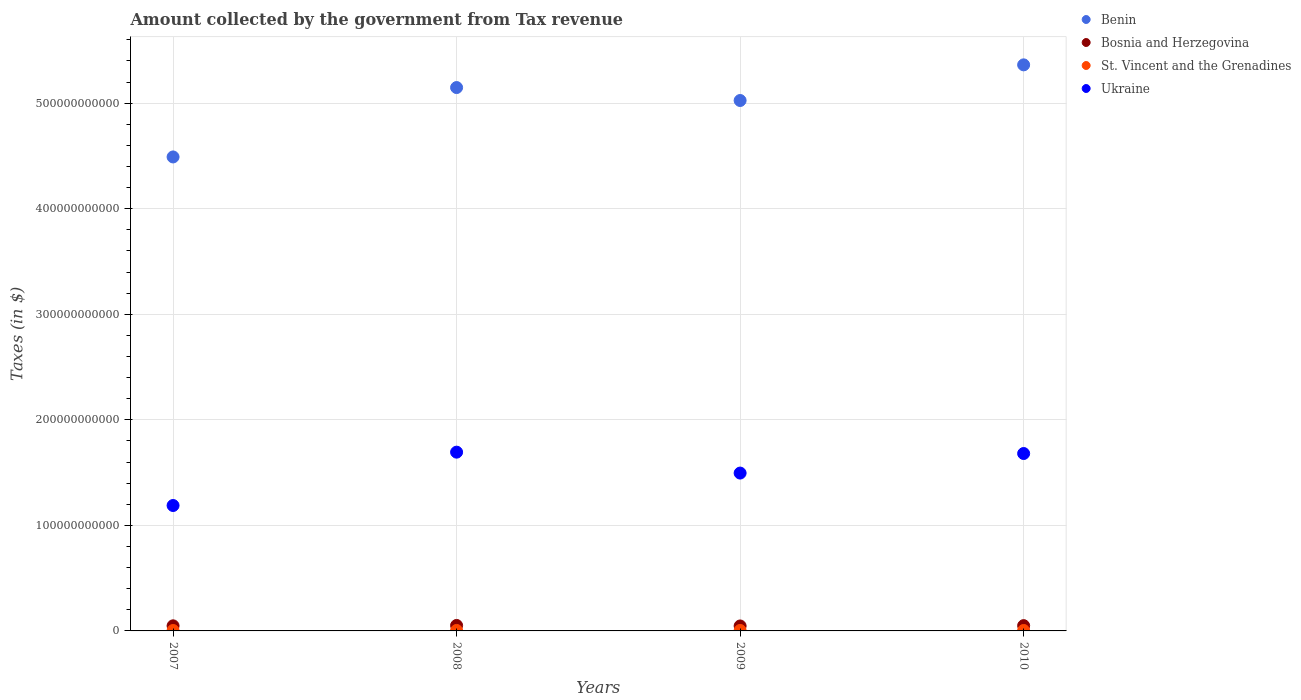What is the amount collected by the government from tax revenue in Bosnia and Herzegovina in 2007?
Your answer should be compact. 4.82e+09. Across all years, what is the maximum amount collected by the government from tax revenue in Bosnia and Herzegovina?
Give a very brief answer. 5.18e+09. Across all years, what is the minimum amount collected by the government from tax revenue in St. Vincent and the Grenadines?
Ensure brevity in your answer.  4.03e+08. In which year was the amount collected by the government from tax revenue in Bosnia and Herzegovina maximum?
Your answer should be very brief. 2008. What is the total amount collected by the government from tax revenue in Bosnia and Herzegovina in the graph?
Offer a terse response. 1.97e+1. What is the difference between the amount collected by the government from tax revenue in Benin in 2007 and that in 2010?
Your response must be concise. -8.72e+1. What is the difference between the amount collected by the government from tax revenue in Bosnia and Herzegovina in 2009 and the amount collected by the government from tax revenue in St. Vincent and the Grenadines in 2010?
Make the answer very short. 4.28e+09. What is the average amount collected by the government from tax revenue in St. Vincent and the Grenadines per year?
Provide a short and direct response. 4.26e+08. In the year 2008, what is the difference between the amount collected by the government from tax revenue in Bosnia and Herzegovina and amount collected by the government from tax revenue in Benin?
Your answer should be compact. -5.10e+11. In how many years, is the amount collected by the government from tax revenue in Bosnia and Herzegovina greater than 300000000000 $?
Provide a succinct answer. 0. What is the ratio of the amount collected by the government from tax revenue in St. Vincent and the Grenadines in 2007 to that in 2008?
Your answer should be compact. 0.9. Is the amount collected by the government from tax revenue in Benin in 2008 less than that in 2009?
Give a very brief answer. No. What is the difference between the highest and the second highest amount collected by the government from tax revenue in St. Vincent and the Grenadines?
Ensure brevity in your answer.  1.54e+07. What is the difference between the highest and the lowest amount collected by the government from tax revenue in St. Vincent and the Grenadines?
Your answer should be very brief. 4.54e+07. Is the sum of the amount collected by the government from tax revenue in Bosnia and Herzegovina in 2008 and 2009 greater than the maximum amount collected by the government from tax revenue in St. Vincent and the Grenadines across all years?
Ensure brevity in your answer.  Yes. Is it the case that in every year, the sum of the amount collected by the government from tax revenue in Ukraine and amount collected by the government from tax revenue in Benin  is greater than the sum of amount collected by the government from tax revenue in St. Vincent and the Grenadines and amount collected by the government from tax revenue in Bosnia and Herzegovina?
Offer a terse response. No. Does the amount collected by the government from tax revenue in Ukraine monotonically increase over the years?
Offer a terse response. No. How many dotlines are there?
Keep it short and to the point. 4. How many years are there in the graph?
Offer a very short reply. 4. What is the difference between two consecutive major ticks on the Y-axis?
Provide a succinct answer. 1.00e+11. Are the values on the major ticks of Y-axis written in scientific E-notation?
Make the answer very short. No. Where does the legend appear in the graph?
Offer a terse response. Top right. How many legend labels are there?
Provide a succinct answer. 4. What is the title of the graph?
Keep it short and to the point. Amount collected by the government from Tax revenue. Does "Denmark" appear as one of the legend labels in the graph?
Provide a short and direct response. No. What is the label or title of the Y-axis?
Offer a terse response. Taxes (in $). What is the Taxes (in $) in Benin in 2007?
Your response must be concise. 4.49e+11. What is the Taxes (in $) in Bosnia and Herzegovina in 2007?
Keep it short and to the point. 4.82e+09. What is the Taxes (in $) of St. Vincent and the Grenadines in 2007?
Ensure brevity in your answer.  4.03e+08. What is the Taxes (in $) in Ukraine in 2007?
Give a very brief answer. 1.19e+11. What is the Taxes (in $) in Benin in 2008?
Offer a very short reply. 5.15e+11. What is the Taxes (in $) of Bosnia and Herzegovina in 2008?
Keep it short and to the point. 5.18e+09. What is the Taxes (in $) in St. Vincent and the Grenadines in 2008?
Your answer should be compact. 4.48e+08. What is the Taxes (in $) of Ukraine in 2008?
Keep it short and to the point. 1.69e+11. What is the Taxes (in $) of Benin in 2009?
Your answer should be compact. 5.02e+11. What is the Taxes (in $) in Bosnia and Herzegovina in 2009?
Your answer should be compact. 4.70e+09. What is the Taxes (in $) in St. Vincent and the Grenadines in 2009?
Your answer should be very brief. 4.33e+08. What is the Taxes (in $) in Ukraine in 2009?
Offer a terse response. 1.50e+11. What is the Taxes (in $) of Benin in 2010?
Offer a terse response. 5.36e+11. What is the Taxes (in $) in Bosnia and Herzegovina in 2010?
Offer a terse response. 4.99e+09. What is the Taxes (in $) in St. Vincent and the Grenadines in 2010?
Provide a succinct answer. 4.22e+08. What is the Taxes (in $) of Ukraine in 2010?
Provide a short and direct response. 1.68e+11. Across all years, what is the maximum Taxes (in $) in Benin?
Offer a very short reply. 5.36e+11. Across all years, what is the maximum Taxes (in $) in Bosnia and Herzegovina?
Give a very brief answer. 5.18e+09. Across all years, what is the maximum Taxes (in $) of St. Vincent and the Grenadines?
Your response must be concise. 4.48e+08. Across all years, what is the maximum Taxes (in $) in Ukraine?
Provide a short and direct response. 1.69e+11. Across all years, what is the minimum Taxes (in $) of Benin?
Offer a terse response. 4.49e+11. Across all years, what is the minimum Taxes (in $) in Bosnia and Herzegovina?
Offer a very short reply. 4.70e+09. Across all years, what is the minimum Taxes (in $) of St. Vincent and the Grenadines?
Offer a terse response. 4.03e+08. Across all years, what is the minimum Taxes (in $) in Ukraine?
Your answer should be compact. 1.19e+11. What is the total Taxes (in $) in Benin in the graph?
Offer a terse response. 2.00e+12. What is the total Taxes (in $) of Bosnia and Herzegovina in the graph?
Ensure brevity in your answer.  1.97e+1. What is the total Taxes (in $) in St. Vincent and the Grenadines in the graph?
Make the answer very short. 1.70e+09. What is the total Taxes (in $) in Ukraine in the graph?
Your answer should be compact. 6.06e+11. What is the difference between the Taxes (in $) in Benin in 2007 and that in 2008?
Your answer should be very brief. -6.57e+1. What is the difference between the Taxes (in $) in Bosnia and Herzegovina in 2007 and that in 2008?
Ensure brevity in your answer.  -3.57e+08. What is the difference between the Taxes (in $) of St. Vincent and the Grenadines in 2007 and that in 2008?
Your response must be concise. -4.54e+07. What is the difference between the Taxes (in $) of Ukraine in 2007 and that in 2008?
Your answer should be compact. -5.05e+1. What is the difference between the Taxes (in $) of Benin in 2007 and that in 2009?
Provide a succinct answer. -5.35e+1. What is the difference between the Taxes (in $) in Bosnia and Herzegovina in 2007 and that in 2009?
Your response must be concise. 1.26e+08. What is the difference between the Taxes (in $) of St. Vincent and the Grenadines in 2007 and that in 2009?
Ensure brevity in your answer.  -3.00e+07. What is the difference between the Taxes (in $) of Ukraine in 2007 and that in 2009?
Make the answer very short. -3.07e+1. What is the difference between the Taxes (in $) in Benin in 2007 and that in 2010?
Give a very brief answer. -8.72e+1. What is the difference between the Taxes (in $) in Bosnia and Herzegovina in 2007 and that in 2010?
Provide a succinct answer. -1.69e+08. What is the difference between the Taxes (in $) in St. Vincent and the Grenadines in 2007 and that in 2010?
Your response must be concise. -1.89e+07. What is the difference between the Taxes (in $) of Ukraine in 2007 and that in 2010?
Make the answer very short. -4.93e+1. What is the difference between the Taxes (in $) in Benin in 2008 and that in 2009?
Your answer should be compact. 1.23e+1. What is the difference between the Taxes (in $) in Bosnia and Herzegovina in 2008 and that in 2009?
Offer a very short reply. 4.83e+08. What is the difference between the Taxes (in $) of St. Vincent and the Grenadines in 2008 and that in 2009?
Offer a terse response. 1.54e+07. What is the difference between the Taxes (in $) of Ukraine in 2008 and that in 2009?
Ensure brevity in your answer.  1.98e+1. What is the difference between the Taxes (in $) in Benin in 2008 and that in 2010?
Your response must be concise. -2.15e+1. What is the difference between the Taxes (in $) in Bosnia and Herzegovina in 2008 and that in 2010?
Your response must be concise. 1.88e+08. What is the difference between the Taxes (in $) in St. Vincent and the Grenadines in 2008 and that in 2010?
Offer a very short reply. 2.65e+07. What is the difference between the Taxes (in $) of Ukraine in 2008 and that in 2010?
Your response must be concise. 1.29e+09. What is the difference between the Taxes (in $) of Benin in 2009 and that in 2010?
Give a very brief answer. -3.38e+1. What is the difference between the Taxes (in $) in Bosnia and Herzegovina in 2009 and that in 2010?
Your answer should be compact. -2.95e+08. What is the difference between the Taxes (in $) of St. Vincent and the Grenadines in 2009 and that in 2010?
Keep it short and to the point. 1.11e+07. What is the difference between the Taxes (in $) of Ukraine in 2009 and that in 2010?
Your response must be concise. -1.85e+1. What is the difference between the Taxes (in $) of Benin in 2007 and the Taxes (in $) of Bosnia and Herzegovina in 2008?
Provide a succinct answer. 4.44e+11. What is the difference between the Taxes (in $) in Benin in 2007 and the Taxes (in $) in St. Vincent and the Grenadines in 2008?
Provide a short and direct response. 4.49e+11. What is the difference between the Taxes (in $) of Benin in 2007 and the Taxes (in $) of Ukraine in 2008?
Your response must be concise. 2.80e+11. What is the difference between the Taxes (in $) in Bosnia and Herzegovina in 2007 and the Taxes (in $) in St. Vincent and the Grenadines in 2008?
Offer a terse response. 4.38e+09. What is the difference between the Taxes (in $) in Bosnia and Herzegovina in 2007 and the Taxes (in $) in Ukraine in 2008?
Provide a succinct answer. -1.65e+11. What is the difference between the Taxes (in $) in St. Vincent and the Grenadines in 2007 and the Taxes (in $) in Ukraine in 2008?
Your response must be concise. -1.69e+11. What is the difference between the Taxes (in $) in Benin in 2007 and the Taxes (in $) in Bosnia and Herzegovina in 2009?
Give a very brief answer. 4.44e+11. What is the difference between the Taxes (in $) in Benin in 2007 and the Taxes (in $) in St. Vincent and the Grenadines in 2009?
Your response must be concise. 4.49e+11. What is the difference between the Taxes (in $) in Benin in 2007 and the Taxes (in $) in Ukraine in 2009?
Your response must be concise. 2.99e+11. What is the difference between the Taxes (in $) in Bosnia and Herzegovina in 2007 and the Taxes (in $) in St. Vincent and the Grenadines in 2009?
Offer a very short reply. 4.39e+09. What is the difference between the Taxes (in $) of Bosnia and Herzegovina in 2007 and the Taxes (in $) of Ukraine in 2009?
Give a very brief answer. -1.45e+11. What is the difference between the Taxes (in $) of St. Vincent and the Grenadines in 2007 and the Taxes (in $) of Ukraine in 2009?
Provide a succinct answer. -1.49e+11. What is the difference between the Taxes (in $) in Benin in 2007 and the Taxes (in $) in Bosnia and Herzegovina in 2010?
Your answer should be compact. 4.44e+11. What is the difference between the Taxes (in $) of Benin in 2007 and the Taxes (in $) of St. Vincent and the Grenadines in 2010?
Keep it short and to the point. 4.49e+11. What is the difference between the Taxes (in $) of Benin in 2007 and the Taxes (in $) of Ukraine in 2010?
Give a very brief answer. 2.81e+11. What is the difference between the Taxes (in $) in Bosnia and Herzegovina in 2007 and the Taxes (in $) in St. Vincent and the Grenadines in 2010?
Keep it short and to the point. 4.40e+09. What is the difference between the Taxes (in $) of Bosnia and Herzegovina in 2007 and the Taxes (in $) of Ukraine in 2010?
Keep it short and to the point. -1.63e+11. What is the difference between the Taxes (in $) of St. Vincent and the Grenadines in 2007 and the Taxes (in $) of Ukraine in 2010?
Offer a terse response. -1.68e+11. What is the difference between the Taxes (in $) of Benin in 2008 and the Taxes (in $) of Bosnia and Herzegovina in 2009?
Provide a short and direct response. 5.10e+11. What is the difference between the Taxes (in $) of Benin in 2008 and the Taxes (in $) of St. Vincent and the Grenadines in 2009?
Your answer should be compact. 5.14e+11. What is the difference between the Taxes (in $) of Benin in 2008 and the Taxes (in $) of Ukraine in 2009?
Give a very brief answer. 3.65e+11. What is the difference between the Taxes (in $) of Bosnia and Herzegovina in 2008 and the Taxes (in $) of St. Vincent and the Grenadines in 2009?
Make the answer very short. 4.75e+09. What is the difference between the Taxes (in $) in Bosnia and Herzegovina in 2008 and the Taxes (in $) in Ukraine in 2009?
Provide a succinct answer. -1.44e+11. What is the difference between the Taxes (in $) of St. Vincent and the Grenadines in 2008 and the Taxes (in $) of Ukraine in 2009?
Ensure brevity in your answer.  -1.49e+11. What is the difference between the Taxes (in $) in Benin in 2008 and the Taxes (in $) in Bosnia and Herzegovina in 2010?
Provide a succinct answer. 5.10e+11. What is the difference between the Taxes (in $) in Benin in 2008 and the Taxes (in $) in St. Vincent and the Grenadines in 2010?
Keep it short and to the point. 5.14e+11. What is the difference between the Taxes (in $) of Benin in 2008 and the Taxes (in $) of Ukraine in 2010?
Make the answer very short. 3.47e+11. What is the difference between the Taxes (in $) in Bosnia and Herzegovina in 2008 and the Taxes (in $) in St. Vincent and the Grenadines in 2010?
Make the answer very short. 4.76e+09. What is the difference between the Taxes (in $) in Bosnia and Herzegovina in 2008 and the Taxes (in $) in Ukraine in 2010?
Your answer should be very brief. -1.63e+11. What is the difference between the Taxes (in $) of St. Vincent and the Grenadines in 2008 and the Taxes (in $) of Ukraine in 2010?
Give a very brief answer. -1.68e+11. What is the difference between the Taxes (in $) in Benin in 2009 and the Taxes (in $) in Bosnia and Herzegovina in 2010?
Provide a short and direct response. 4.97e+11. What is the difference between the Taxes (in $) of Benin in 2009 and the Taxes (in $) of St. Vincent and the Grenadines in 2010?
Your response must be concise. 5.02e+11. What is the difference between the Taxes (in $) of Benin in 2009 and the Taxes (in $) of Ukraine in 2010?
Offer a very short reply. 3.34e+11. What is the difference between the Taxes (in $) in Bosnia and Herzegovina in 2009 and the Taxes (in $) in St. Vincent and the Grenadines in 2010?
Your answer should be very brief. 4.28e+09. What is the difference between the Taxes (in $) of Bosnia and Herzegovina in 2009 and the Taxes (in $) of Ukraine in 2010?
Give a very brief answer. -1.63e+11. What is the difference between the Taxes (in $) of St. Vincent and the Grenadines in 2009 and the Taxes (in $) of Ukraine in 2010?
Provide a succinct answer. -1.68e+11. What is the average Taxes (in $) of Benin per year?
Your response must be concise. 5.01e+11. What is the average Taxes (in $) in Bosnia and Herzegovina per year?
Give a very brief answer. 4.92e+09. What is the average Taxes (in $) of St. Vincent and the Grenadines per year?
Provide a short and direct response. 4.26e+08. What is the average Taxes (in $) in Ukraine per year?
Ensure brevity in your answer.  1.51e+11. In the year 2007, what is the difference between the Taxes (in $) of Benin and Taxes (in $) of Bosnia and Herzegovina?
Provide a short and direct response. 4.44e+11. In the year 2007, what is the difference between the Taxes (in $) in Benin and Taxes (in $) in St. Vincent and the Grenadines?
Offer a terse response. 4.49e+11. In the year 2007, what is the difference between the Taxes (in $) of Benin and Taxes (in $) of Ukraine?
Provide a short and direct response. 3.30e+11. In the year 2007, what is the difference between the Taxes (in $) in Bosnia and Herzegovina and Taxes (in $) in St. Vincent and the Grenadines?
Ensure brevity in your answer.  4.42e+09. In the year 2007, what is the difference between the Taxes (in $) of Bosnia and Herzegovina and Taxes (in $) of Ukraine?
Give a very brief answer. -1.14e+11. In the year 2007, what is the difference between the Taxes (in $) in St. Vincent and the Grenadines and Taxes (in $) in Ukraine?
Your answer should be very brief. -1.18e+11. In the year 2008, what is the difference between the Taxes (in $) in Benin and Taxes (in $) in Bosnia and Herzegovina?
Keep it short and to the point. 5.10e+11. In the year 2008, what is the difference between the Taxes (in $) in Benin and Taxes (in $) in St. Vincent and the Grenadines?
Ensure brevity in your answer.  5.14e+11. In the year 2008, what is the difference between the Taxes (in $) in Benin and Taxes (in $) in Ukraine?
Provide a succinct answer. 3.45e+11. In the year 2008, what is the difference between the Taxes (in $) of Bosnia and Herzegovina and Taxes (in $) of St. Vincent and the Grenadines?
Keep it short and to the point. 4.73e+09. In the year 2008, what is the difference between the Taxes (in $) in Bosnia and Herzegovina and Taxes (in $) in Ukraine?
Give a very brief answer. -1.64e+11. In the year 2008, what is the difference between the Taxes (in $) of St. Vincent and the Grenadines and Taxes (in $) of Ukraine?
Provide a succinct answer. -1.69e+11. In the year 2009, what is the difference between the Taxes (in $) of Benin and Taxes (in $) of Bosnia and Herzegovina?
Keep it short and to the point. 4.98e+11. In the year 2009, what is the difference between the Taxes (in $) in Benin and Taxes (in $) in St. Vincent and the Grenadines?
Make the answer very short. 5.02e+11. In the year 2009, what is the difference between the Taxes (in $) in Benin and Taxes (in $) in Ukraine?
Provide a short and direct response. 3.53e+11. In the year 2009, what is the difference between the Taxes (in $) of Bosnia and Herzegovina and Taxes (in $) of St. Vincent and the Grenadines?
Give a very brief answer. 4.27e+09. In the year 2009, what is the difference between the Taxes (in $) of Bosnia and Herzegovina and Taxes (in $) of Ukraine?
Provide a succinct answer. -1.45e+11. In the year 2009, what is the difference between the Taxes (in $) in St. Vincent and the Grenadines and Taxes (in $) in Ukraine?
Provide a short and direct response. -1.49e+11. In the year 2010, what is the difference between the Taxes (in $) of Benin and Taxes (in $) of Bosnia and Herzegovina?
Provide a succinct answer. 5.31e+11. In the year 2010, what is the difference between the Taxes (in $) of Benin and Taxes (in $) of St. Vincent and the Grenadines?
Your answer should be very brief. 5.36e+11. In the year 2010, what is the difference between the Taxes (in $) of Benin and Taxes (in $) of Ukraine?
Offer a very short reply. 3.68e+11. In the year 2010, what is the difference between the Taxes (in $) in Bosnia and Herzegovina and Taxes (in $) in St. Vincent and the Grenadines?
Keep it short and to the point. 4.57e+09. In the year 2010, what is the difference between the Taxes (in $) of Bosnia and Herzegovina and Taxes (in $) of Ukraine?
Provide a succinct answer. -1.63e+11. In the year 2010, what is the difference between the Taxes (in $) of St. Vincent and the Grenadines and Taxes (in $) of Ukraine?
Your answer should be very brief. -1.68e+11. What is the ratio of the Taxes (in $) in Benin in 2007 to that in 2008?
Provide a short and direct response. 0.87. What is the ratio of the Taxes (in $) in Bosnia and Herzegovina in 2007 to that in 2008?
Offer a very short reply. 0.93. What is the ratio of the Taxes (in $) of St. Vincent and the Grenadines in 2007 to that in 2008?
Your response must be concise. 0.9. What is the ratio of the Taxes (in $) in Ukraine in 2007 to that in 2008?
Keep it short and to the point. 0.7. What is the ratio of the Taxes (in $) of Benin in 2007 to that in 2009?
Provide a succinct answer. 0.89. What is the ratio of the Taxes (in $) in Bosnia and Herzegovina in 2007 to that in 2009?
Provide a succinct answer. 1.03. What is the ratio of the Taxes (in $) in St. Vincent and the Grenadines in 2007 to that in 2009?
Make the answer very short. 0.93. What is the ratio of the Taxes (in $) of Ukraine in 2007 to that in 2009?
Give a very brief answer. 0.79. What is the ratio of the Taxes (in $) in Benin in 2007 to that in 2010?
Your response must be concise. 0.84. What is the ratio of the Taxes (in $) in Bosnia and Herzegovina in 2007 to that in 2010?
Give a very brief answer. 0.97. What is the ratio of the Taxes (in $) of St. Vincent and the Grenadines in 2007 to that in 2010?
Ensure brevity in your answer.  0.96. What is the ratio of the Taxes (in $) of Ukraine in 2007 to that in 2010?
Offer a terse response. 0.71. What is the ratio of the Taxes (in $) in Benin in 2008 to that in 2009?
Provide a succinct answer. 1.02. What is the ratio of the Taxes (in $) of Bosnia and Herzegovina in 2008 to that in 2009?
Give a very brief answer. 1.1. What is the ratio of the Taxes (in $) in St. Vincent and the Grenadines in 2008 to that in 2009?
Your response must be concise. 1.04. What is the ratio of the Taxes (in $) of Ukraine in 2008 to that in 2009?
Your answer should be very brief. 1.13. What is the ratio of the Taxes (in $) in Benin in 2008 to that in 2010?
Make the answer very short. 0.96. What is the ratio of the Taxes (in $) in Bosnia and Herzegovina in 2008 to that in 2010?
Keep it short and to the point. 1.04. What is the ratio of the Taxes (in $) in St. Vincent and the Grenadines in 2008 to that in 2010?
Your response must be concise. 1.06. What is the ratio of the Taxes (in $) of Ukraine in 2008 to that in 2010?
Your answer should be compact. 1.01. What is the ratio of the Taxes (in $) of Benin in 2009 to that in 2010?
Give a very brief answer. 0.94. What is the ratio of the Taxes (in $) in Bosnia and Herzegovina in 2009 to that in 2010?
Your answer should be very brief. 0.94. What is the ratio of the Taxes (in $) in St. Vincent and the Grenadines in 2009 to that in 2010?
Your answer should be compact. 1.03. What is the ratio of the Taxes (in $) in Ukraine in 2009 to that in 2010?
Offer a very short reply. 0.89. What is the difference between the highest and the second highest Taxes (in $) of Benin?
Make the answer very short. 2.15e+1. What is the difference between the highest and the second highest Taxes (in $) of Bosnia and Herzegovina?
Offer a very short reply. 1.88e+08. What is the difference between the highest and the second highest Taxes (in $) in St. Vincent and the Grenadines?
Ensure brevity in your answer.  1.54e+07. What is the difference between the highest and the second highest Taxes (in $) in Ukraine?
Your response must be concise. 1.29e+09. What is the difference between the highest and the lowest Taxes (in $) in Benin?
Offer a terse response. 8.72e+1. What is the difference between the highest and the lowest Taxes (in $) in Bosnia and Herzegovina?
Ensure brevity in your answer.  4.83e+08. What is the difference between the highest and the lowest Taxes (in $) of St. Vincent and the Grenadines?
Your response must be concise. 4.54e+07. What is the difference between the highest and the lowest Taxes (in $) of Ukraine?
Offer a terse response. 5.05e+1. 